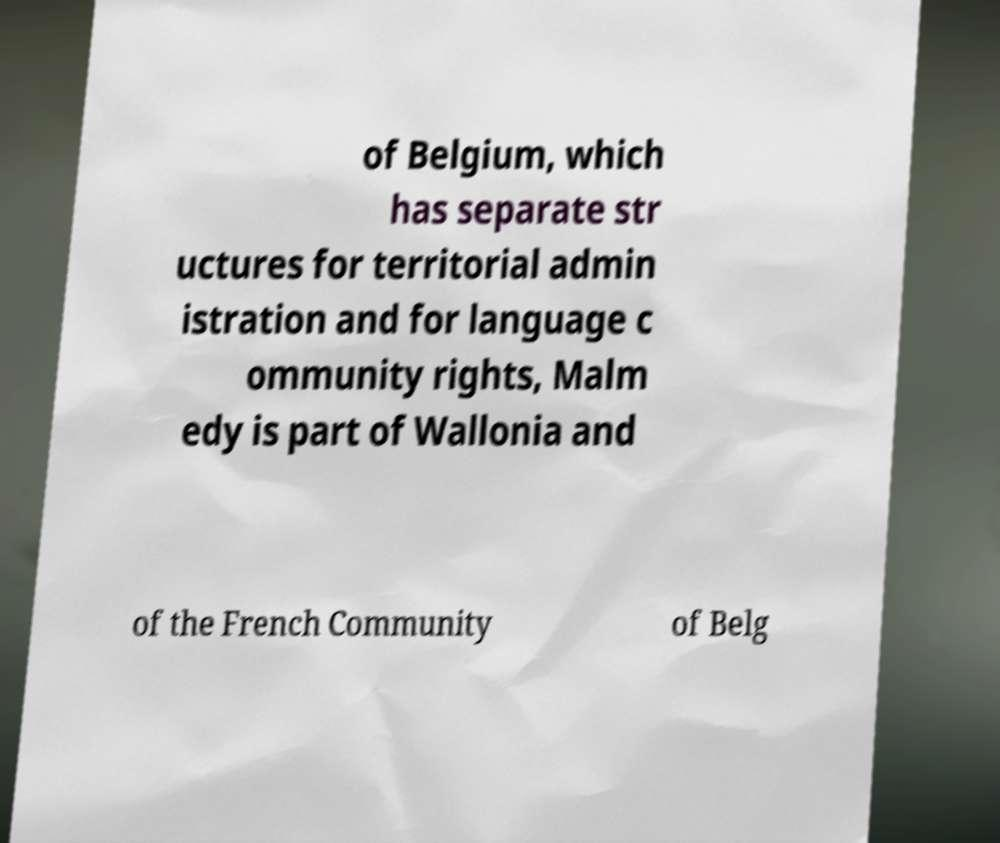Can you read and provide the text displayed in the image?This photo seems to have some interesting text. Can you extract and type it out for me? of Belgium, which has separate str uctures for territorial admin istration and for language c ommunity rights, Malm edy is part of Wallonia and of the French Community of Belg 